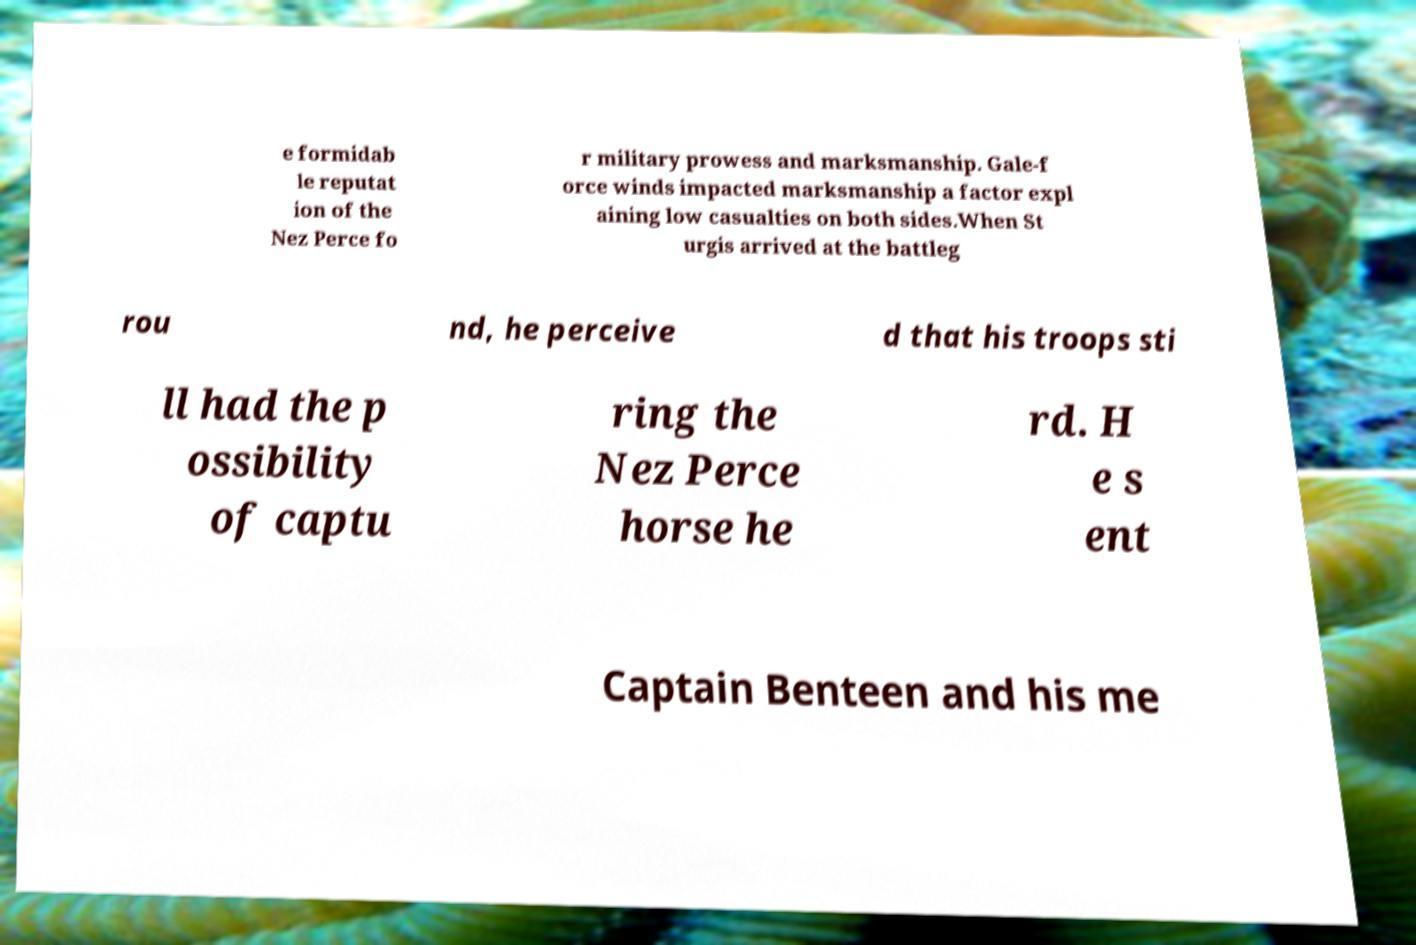For documentation purposes, I need the text within this image transcribed. Could you provide that? e formidab le reputat ion of the Nez Perce fo r military prowess and marksmanship. Gale-f orce winds impacted marksmanship a factor expl aining low casualties on both sides.When St urgis arrived at the battleg rou nd, he perceive d that his troops sti ll had the p ossibility of captu ring the Nez Perce horse he rd. H e s ent Captain Benteen and his me 